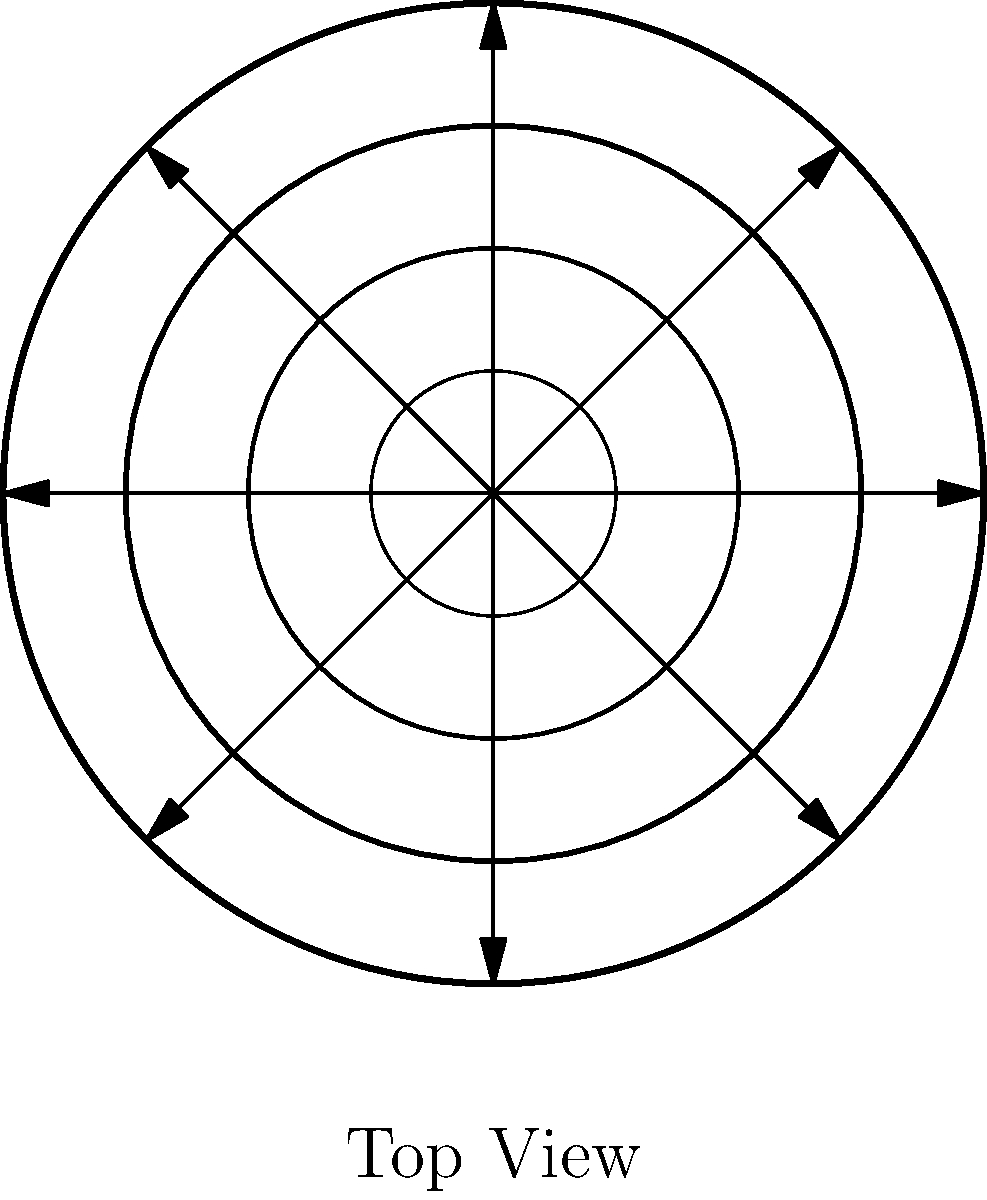In Renaissance garden fountains, a common design principle was the use of concentric circles representing different tiers. If you were to rotate the fountain design shown above by 22.5 degrees clockwise, how many of the decorative arrows would align perfectly with the spaces between the existing arrows? To solve this problem, we need to follow these steps:

1. Understand the current arrangement:
   - The fountain design has 8 decorative arrows arranged at 45-degree intervals.
   - The arrows point outward from the center of the fountain.

2. Visualize the rotation:
   - We need to mentally rotate the entire design by 22.5 degrees clockwise.
   - 22.5 degrees is exactly half of the 45-degree interval between the current arrows.

3. Analyze the new positions:
   - After rotation, each arrow will be positioned halfway between two of the original arrow positions.
   - This means that every arrow in the rotated design will align perfectly with the spaces between the existing arrows.

4. Count the aligned arrows:
   - Since there are 8 arrows in total, and each one will align with a space after rotation, all 8 arrows will be perfectly aligned with the spaces.

5. Confirm the answer:
   - The question asks for the number of arrows that would align perfectly with the spaces between existing arrows.
   - We determined that all 8 arrows would align in this way.

Therefore, the answer is 8 arrows.
Answer: 8 